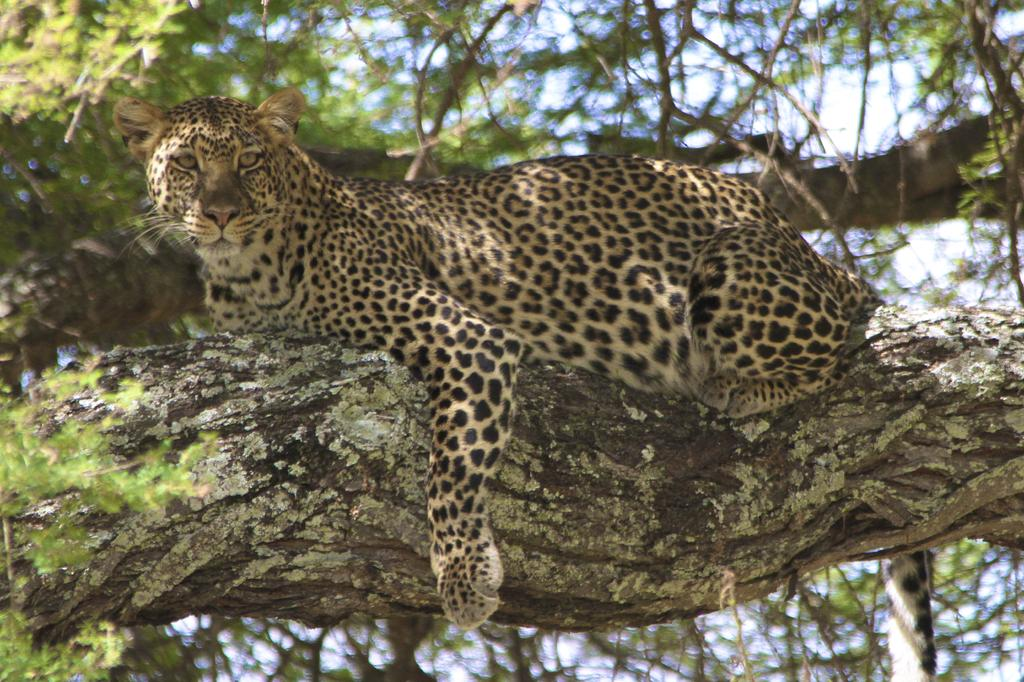What animal is in the image? There is a leopard in the image. Where is the leopard located? The leopard is on a branch of a tree. Can you describe the background of the image? The background of the image is blurred. What type of tax is being discussed in the image? There is no discussion of tax in the image; it features a leopard on a tree branch with a blurred background. 